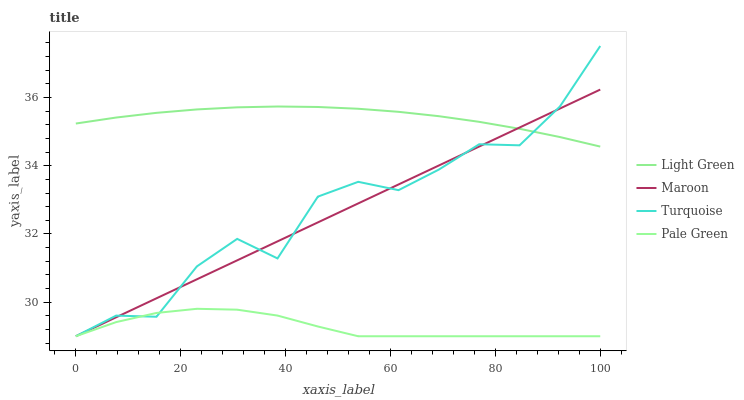Does Pale Green have the minimum area under the curve?
Answer yes or no. Yes. Does Light Green have the maximum area under the curve?
Answer yes or no. Yes. Does Maroon have the minimum area under the curve?
Answer yes or no. No. Does Maroon have the maximum area under the curve?
Answer yes or no. No. Is Maroon the smoothest?
Answer yes or no. Yes. Is Turquoise the roughest?
Answer yes or no. Yes. Is Pale Green the smoothest?
Answer yes or no. No. Is Pale Green the roughest?
Answer yes or no. No. Does Turquoise have the lowest value?
Answer yes or no. Yes. Does Light Green have the lowest value?
Answer yes or no. No. Does Turquoise have the highest value?
Answer yes or no. Yes. Does Maroon have the highest value?
Answer yes or no. No. Is Pale Green less than Light Green?
Answer yes or no. Yes. Is Light Green greater than Pale Green?
Answer yes or no. Yes. Does Pale Green intersect Maroon?
Answer yes or no. Yes. Is Pale Green less than Maroon?
Answer yes or no. No. Is Pale Green greater than Maroon?
Answer yes or no. No. Does Pale Green intersect Light Green?
Answer yes or no. No. 